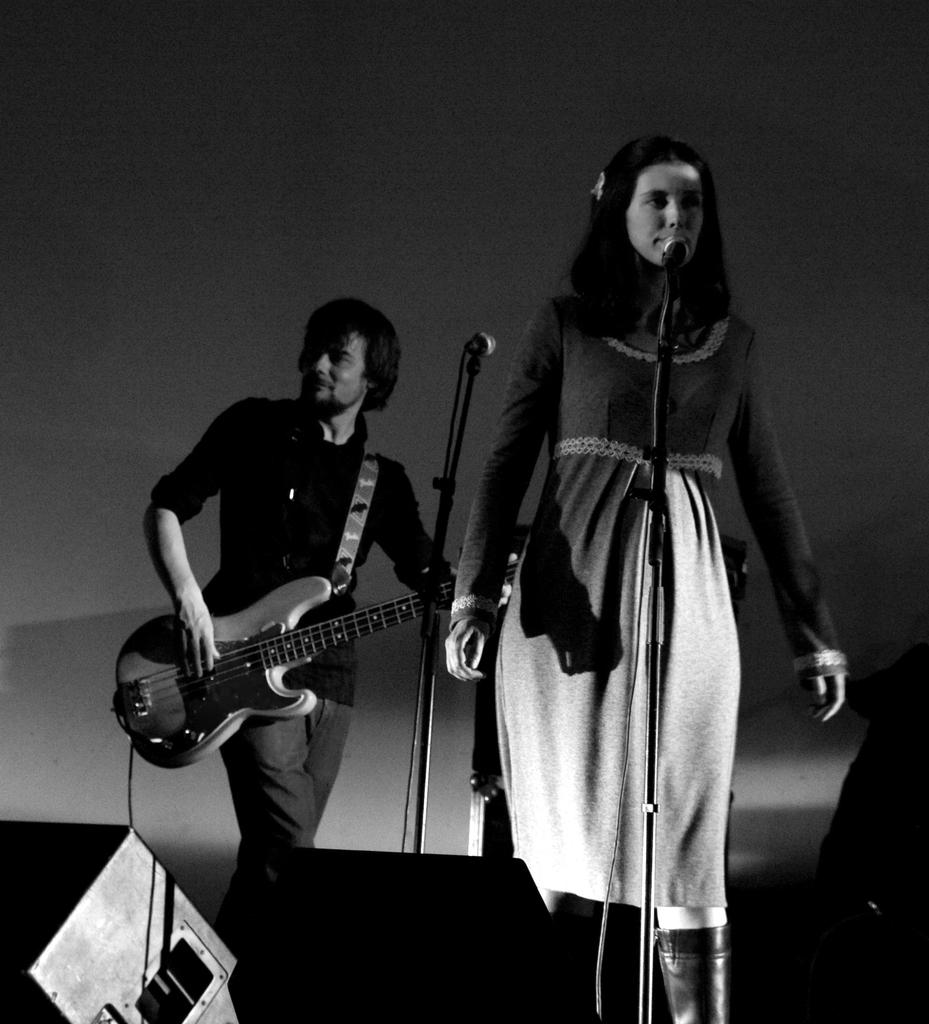What is the man in the image doing? The man is standing and playing the guitar. What is the woman in the image doing? The woman is singing on a microphone. Where are the man and woman located in the image? Both the man and woman are on a stage. What is the color scheme of the image? The image is black and white. How many feet of coil are visible in the image? There is no coil present in the image. What type of lift is being used by the man in the image? The man is not using any lift in the image; he is standing on the stage. 